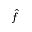Convert formula to latex. <formula><loc_0><loc_0><loc_500><loc_500>\hat { f }</formula> 